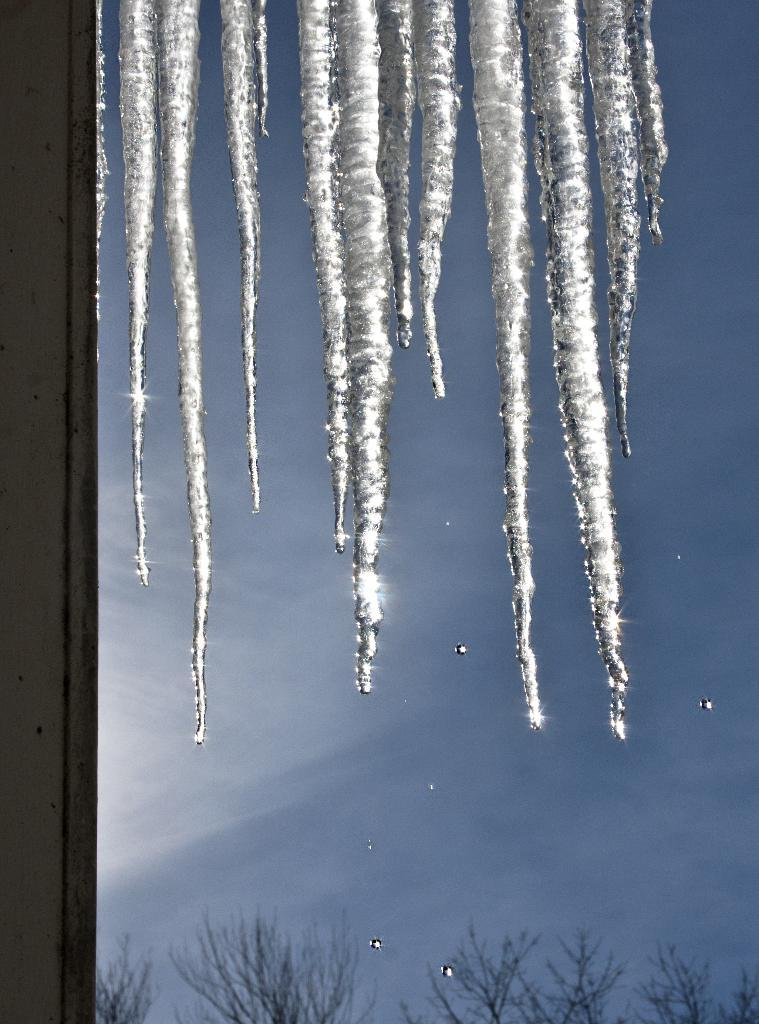What is the primary element present in the picture? There is ice in the picture. What type of natural environment is depicted in the picture? There are trees in the picture, which suggests a forest or wooded area. What can be seen in the background of the picture? The sky is visible in the picture. Can you describe the object on the left side of the picture? There is an unspecified object on the left side of the picture, but its details are not clear from the provided facts. What shape is the discovery made by the explorers in the picture? There is no mention of explorers or a discovery in the picture, so this question cannot be answered definitively. 